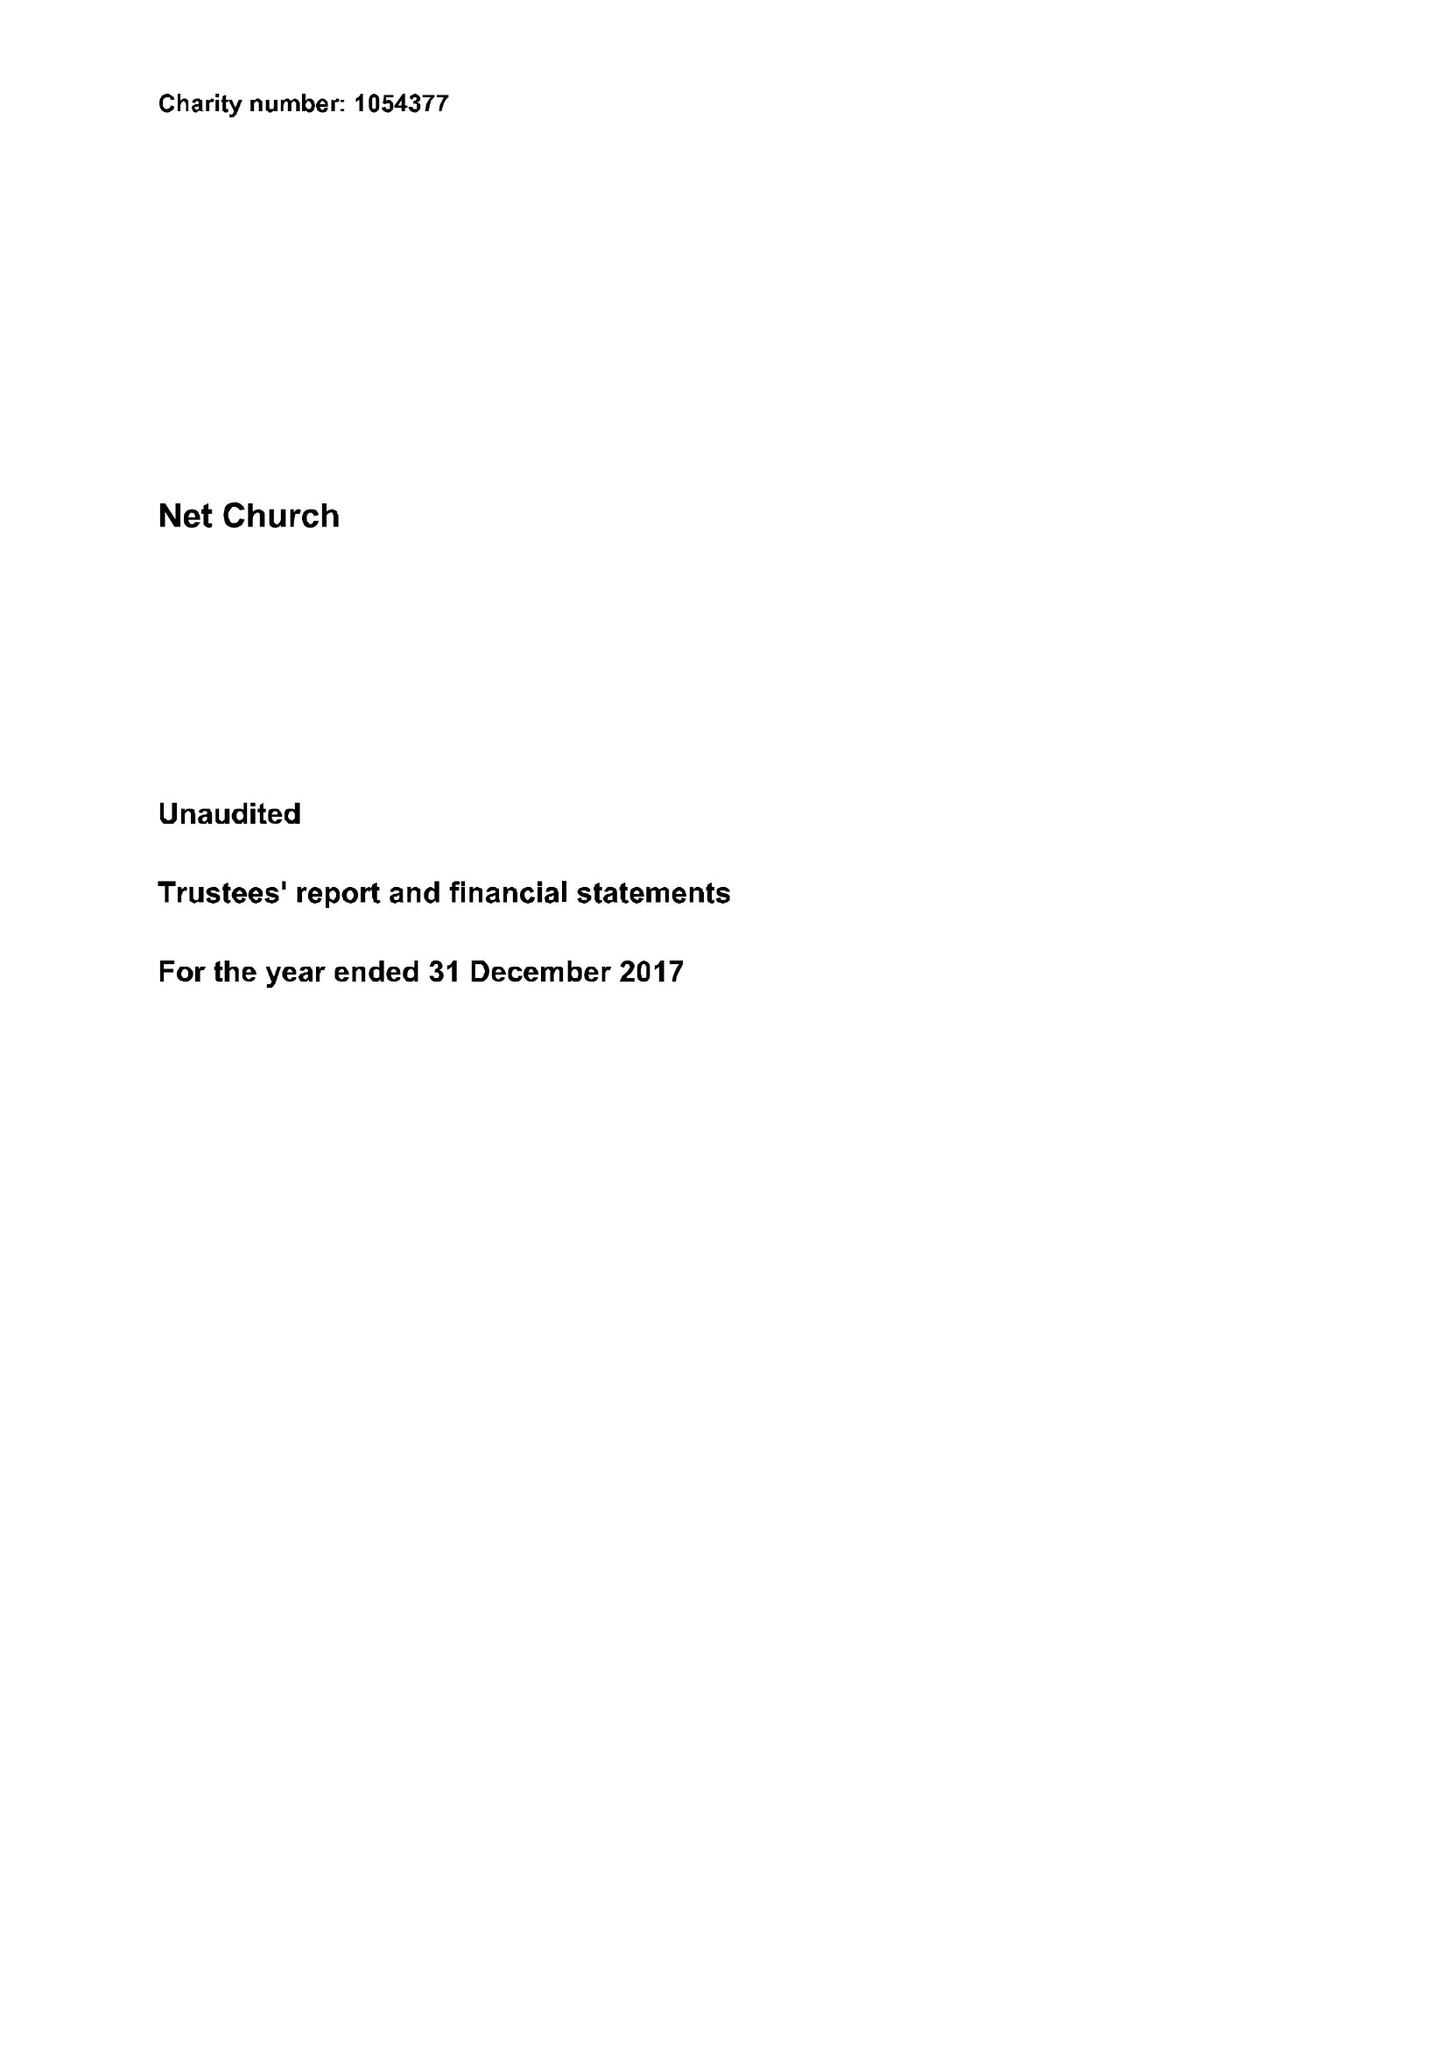What is the value for the spending_annually_in_british_pounds?
Answer the question using a single word or phrase. 182685.00 